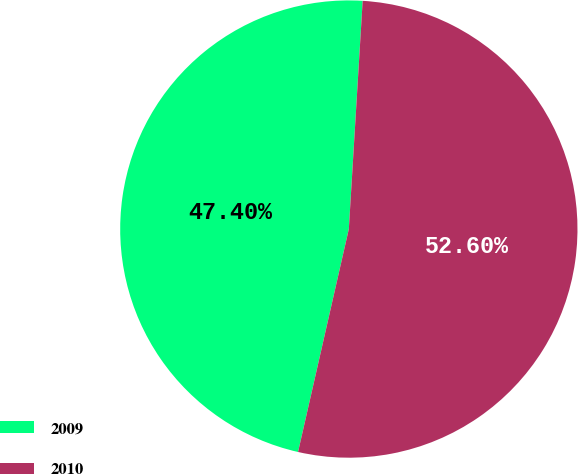<chart> <loc_0><loc_0><loc_500><loc_500><pie_chart><fcel>2009<fcel>2010<nl><fcel>47.4%<fcel>52.6%<nl></chart> 